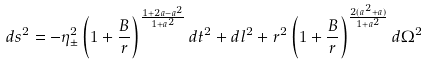Convert formula to latex. <formula><loc_0><loc_0><loc_500><loc_500>d s ^ { 2 } = - \eta ^ { 2 } _ { \pm } \left ( 1 + \frac { B } { r } \right ) ^ { \frac { 1 + 2 a - a ^ { 2 } } { 1 + a ^ { 2 } } } d t ^ { 2 } + d l ^ { 2 } + r ^ { 2 } \left ( 1 + \frac { B } { r } \right ) ^ { \frac { 2 ( a ^ { 2 } + a ) } { 1 + a ^ { 2 } } } d \Omega ^ { 2 }</formula> 